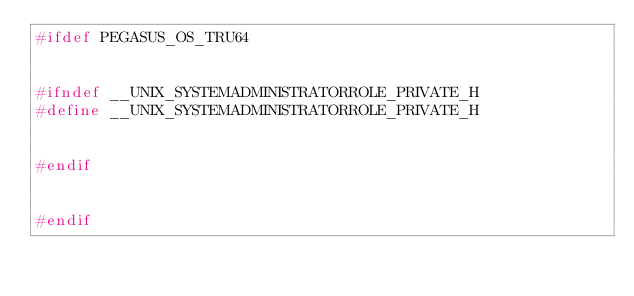Convert code to text. <code><loc_0><loc_0><loc_500><loc_500><_C++_>#ifdef PEGASUS_OS_TRU64


#ifndef __UNIX_SYSTEMADMINISTRATORROLE_PRIVATE_H
#define __UNIX_SYSTEMADMINISTRATORROLE_PRIVATE_H


#endif


#endif
</code> 